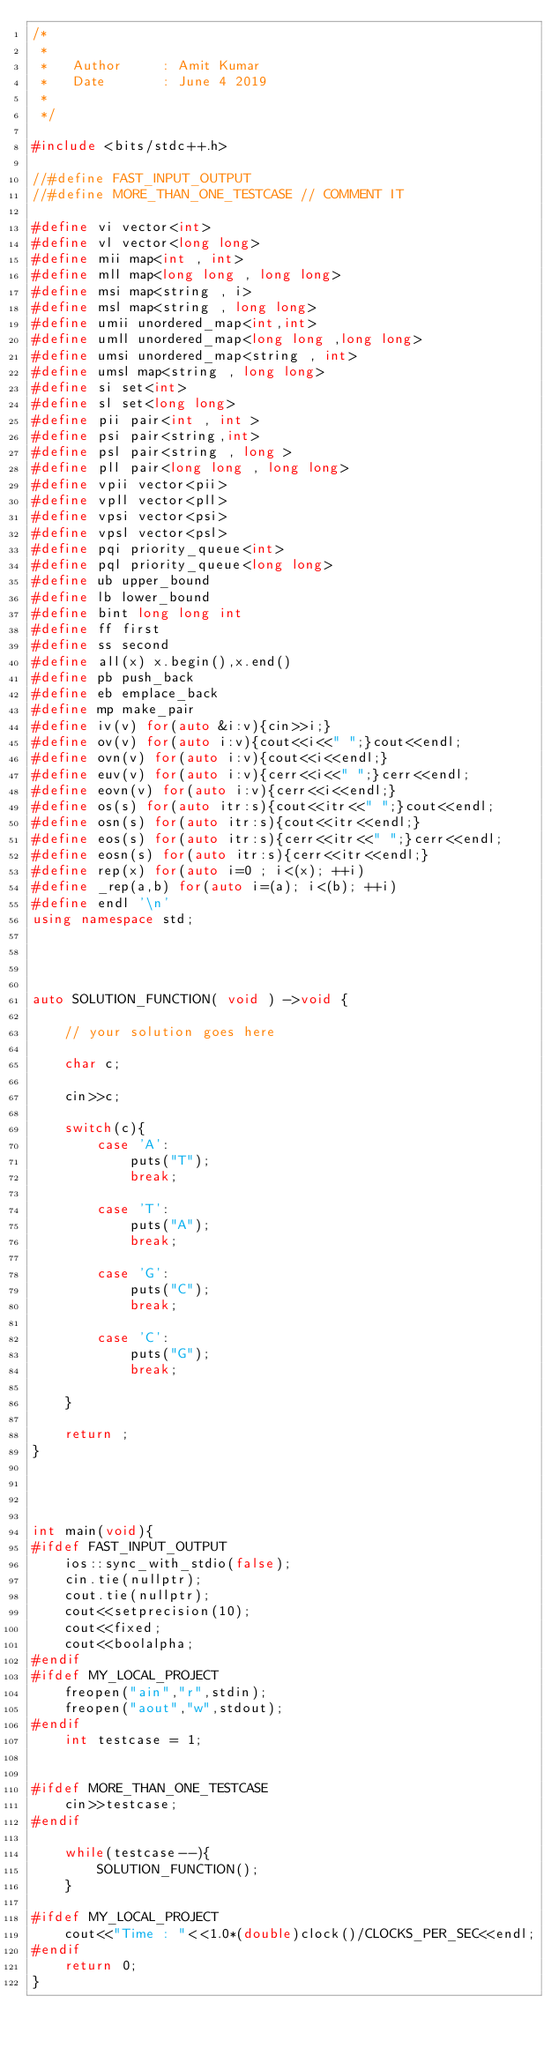<code> <loc_0><loc_0><loc_500><loc_500><_C++_>/*
 *
 *   Author     : Amit Kumar
 *   Date    	: June 4 2019
 * 
 */

#include <bits/stdc++.h>

//#define FAST_INPUT_OUTPUT
//#define MORE_THAN_ONE_TESTCASE // COMMENT IT

#define vi vector<int>
#define vl vector<long long>
#define mii map<int , int>
#define mll map<long long , long long>
#define msi map<string , i>
#define msl map<string , long long>
#define umii unordered_map<int,int>
#define umll unordered_map<long long ,long long>
#define umsi unordered_map<string , int>
#define umsl map<string , long long> 
#define si set<int>
#define sl set<long long>
#define pii pair<int , int >
#define psi pair<string,int>
#define psl pair<string , long > 
#define pll pair<long long , long long>
#define vpii vector<pii>
#define vpll vector<pll>
#define vpsi vector<psi>
#define vpsl vector<psl>
#define pqi priority_queue<int>
#define pql priority_queue<long long>
#define ub upper_bound
#define lb lower_bound
#define bint long long int
#define ff first
#define ss second
#define all(x) x.begin(),x.end()
#define pb push_back
#define eb emplace_back
#define mp make_pair
#define iv(v) for(auto &i:v){cin>>i;}
#define ov(v) for(auto i:v){cout<<i<<" ";}cout<<endl;
#define ovn(v) for(auto i:v){cout<<i<<endl;}
#define euv(v) for(auto i:v){cerr<<i<<" ";}cerr<<endl;
#define eovn(v) for(auto i:v){cerr<<i<<endl;}
#define os(s) for(auto itr:s){cout<<itr<<" ";}cout<<endl;
#define osn(s) for(auto itr:s){cout<<itr<<endl;}
#define eos(s) for(auto itr:s){cerr<<itr<<" ";}cerr<<endl;
#define eosn(s) for(auto itr:s){cerr<<itr<<endl;}
#define rep(x) for(auto i=0 ; i<(x); ++i)
#define _rep(a,b) for(auto i=(a); i<(b); ++i)
#define endl '\n'
using namespace std;




auto SOLUTION_FUNCTION( void ) ->void {

    // your solution goes here 

    char c;

    cin>>c;

    switch(c){
        case 'A':
            puts("T");
            break;

        case 'T':
            puts("A");
            break;

        case 'G':
            puts("C");
            break;

        case 'C':
            puts("G");
            break;

    }

    return ;
}




int main(void){
#ifdef FAST_INPUT_OUTPUT
    ios::sync_with_stdio(false);
    cin.tie(nullptr);
    cout.tie(nullptr);
    cout<<setprecision(10);
    cout<<fixed;
    cout<<boolalpha;
#endif
#ifdef MY_LOCAL_PROJECT
    freopen("ain","r",stdin);
    freopen("aout","w",stdout);
#endif
    int testcase = 1;


#ifdef MORE_THAN_ONE_TESTCASE
    cin>>testcase;
#endif
    
    while(testcase--){
        SOLUTION_FUNCTION();
    }

#ifdef MY_LOCAL_PROJECT
    cout<<"Time : "<<1.0*(double)clock()/CLOCKS_PER_SEC<<endl;
#endif
    return 0;
}</code> 